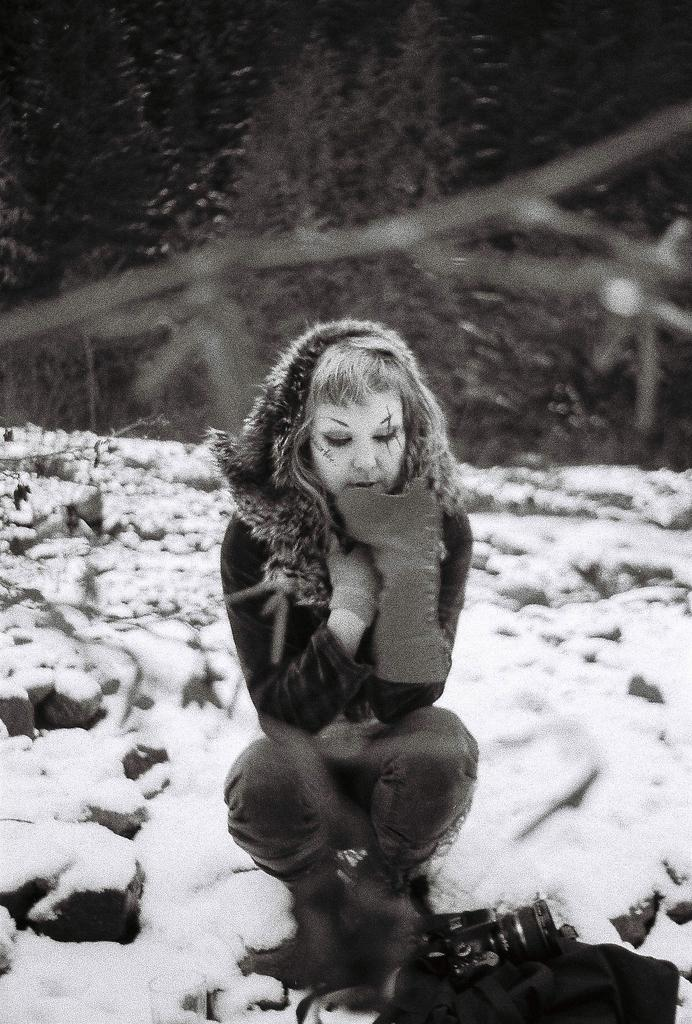What is the woman in the image doing? The woman is sitting on the floor in the image. What can be seen in the background of the image? There is snow and trees visible in the background of the image. What type of poisonous plant is the woman holding in the image? There is no plant, poisonous or otherwise, visible in the image. The woman is simply sitting on the floor with no objects in her hands. 